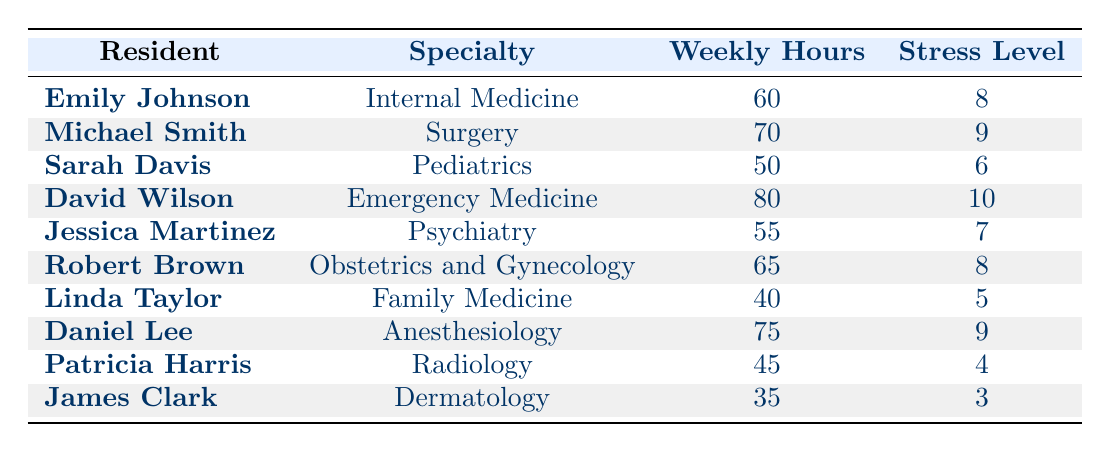What is the weekly hour workload of Sarah Davis? The table displays Sarah Davis's weekly hours in the "Weekly Hours" column. According to the data, she worked 50 hours per week.
Answer: 50 What is the stress level reported by David Wilson? From the table, David Wilson's reported stress level can be found in the "Stress Level" column, where it shows that he reported a stress level of 10.
Answer: 10 Which resident has the lowest reported stress level? To find the resident with the lowest stress level, we refer to the stress levels in the table. James Clark has the lowest reported stress level of 3.
Answer: James Clark What is the average weekly hour workload of all residents? To calculate the average, we sum the weekly hours: 60 + 70 + 50 + 80 + 55 + 65 + 40 + 75 + 45 + 35 = 675. There are 10 residents, so the average is 675 / 10 = 67.5.
Answer: 67.5 Is Linda Taylor's weekly workload greater than that of Robert Brown? To answer this, we compare the "Weekly Hours" columns for Linda Taylor (40 hours) and Robert Brown (65 hours). Since 40 is less than 65, Linda Taylor's workload is not greater than Robert Brown's.
Answer: No What specialty has the highest reported stress level? We check the "Stress Level" column for the highest value. David Wilson, with a stress level of 10 in Emergency Medicine, has the highest reported stress level.
Answer: Emergency Medicine How many residents reported a stress level of 8 or above? We need to count the residents with a stress level of 8 or higher. The relevant residents are Emily Johnson, Michael Smith, David Wilson, and Daniel Lee, making a total of 4 residents.
Answer: 4 Calculate the difference in stress levels between the resident with the highest and the lowest stress levels. The highest stress level is 10 (David Wilson), and the lowest is 3 (James Clark). The difference is 10 - 3 = 7.
Answer: 7 Do any residents work less than 40 hours per week? By examining the "Weekly Hours" column, all residents work 35 hours (James Clark) or more, so no residents work less than 40 hours.
Answer: No 